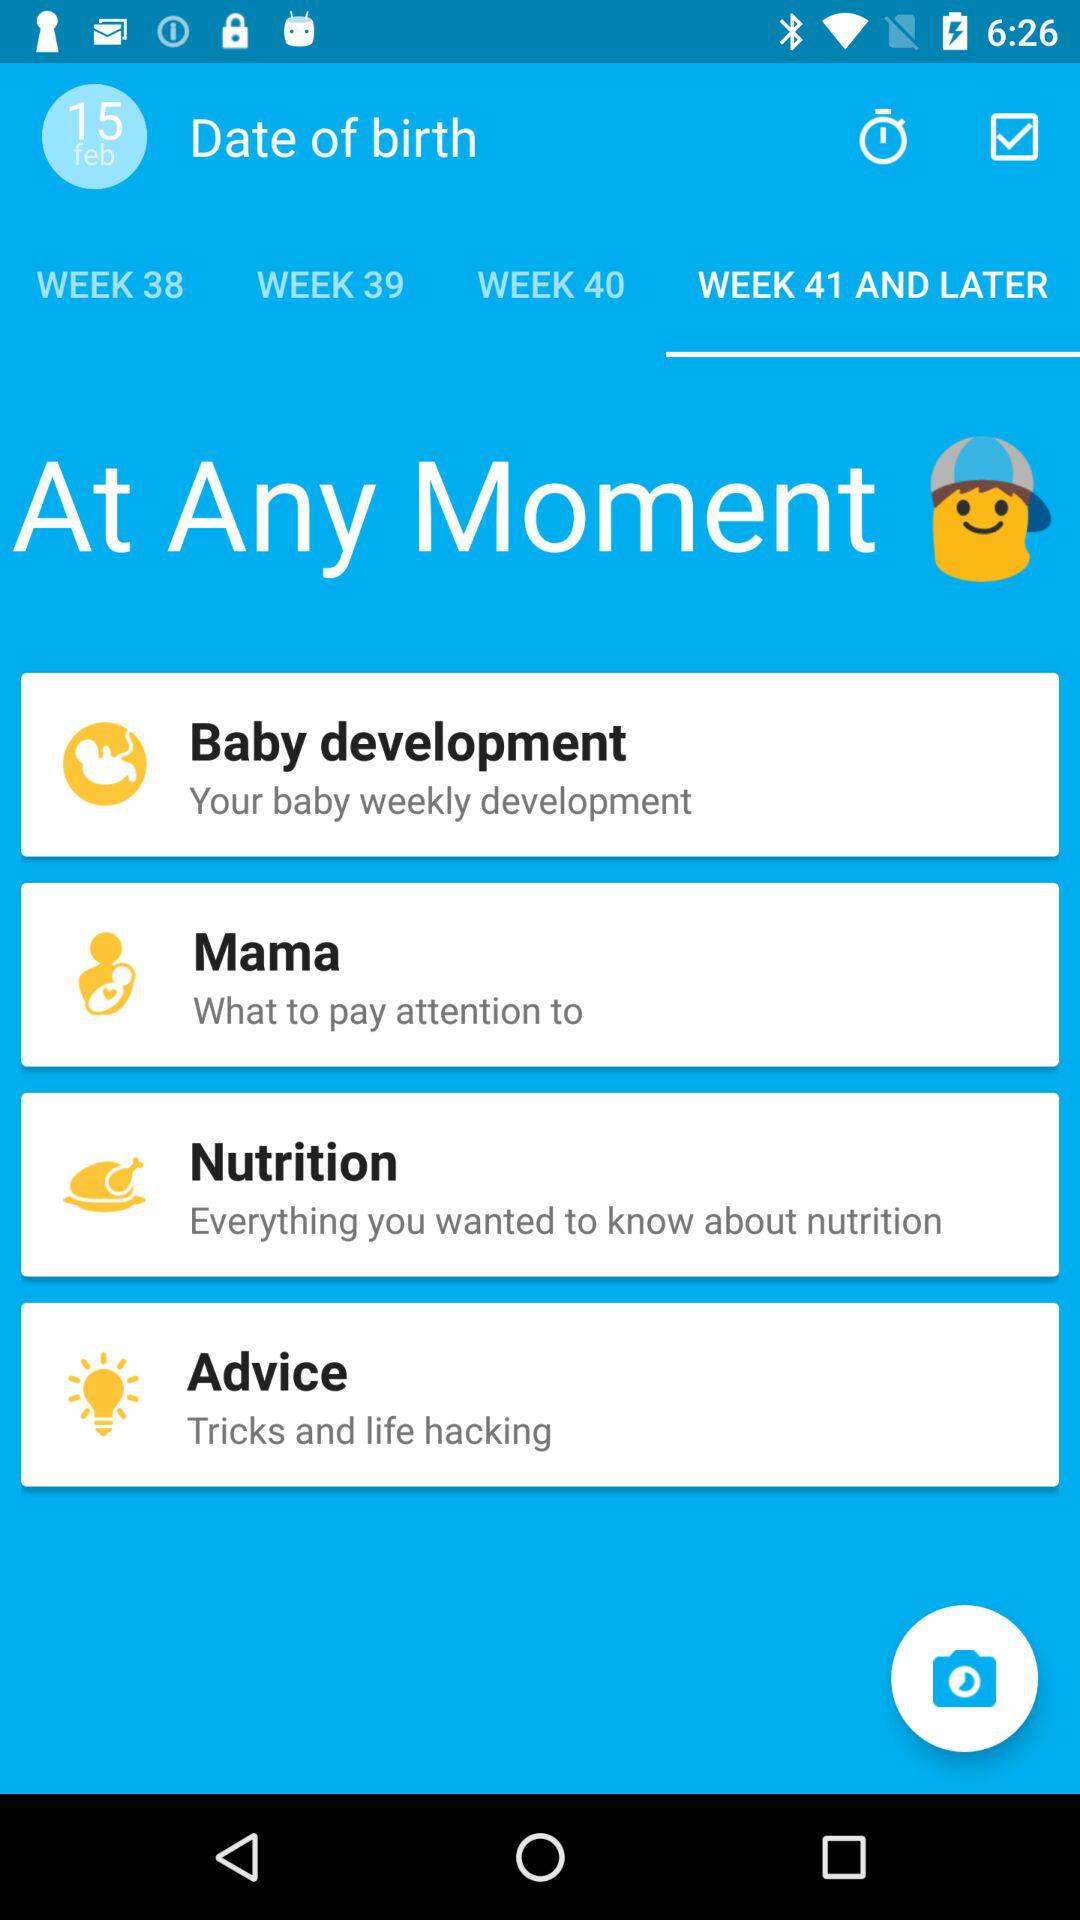What is the date that has been mentioned? The date that has been mentioned is February 15. 